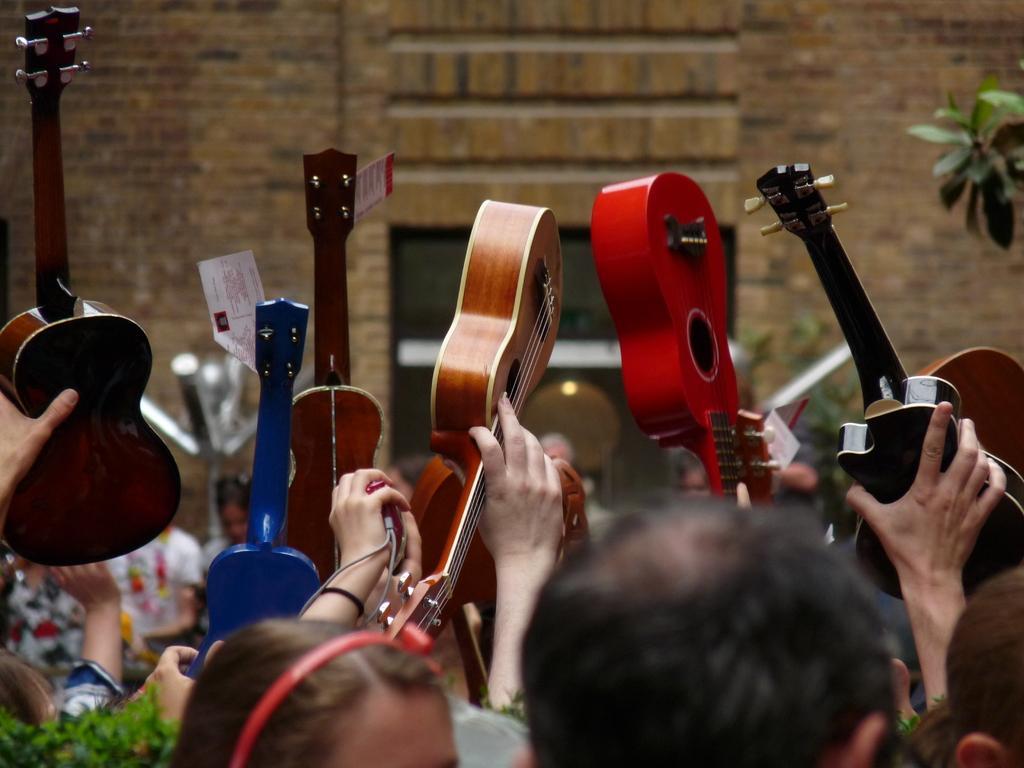Could you give a brief overview of what you see in this image? Persons are raising their hands and holding this colorful guitars. We can able to see planets right side of the image and left side of the image. A rate tags on this guitars. 